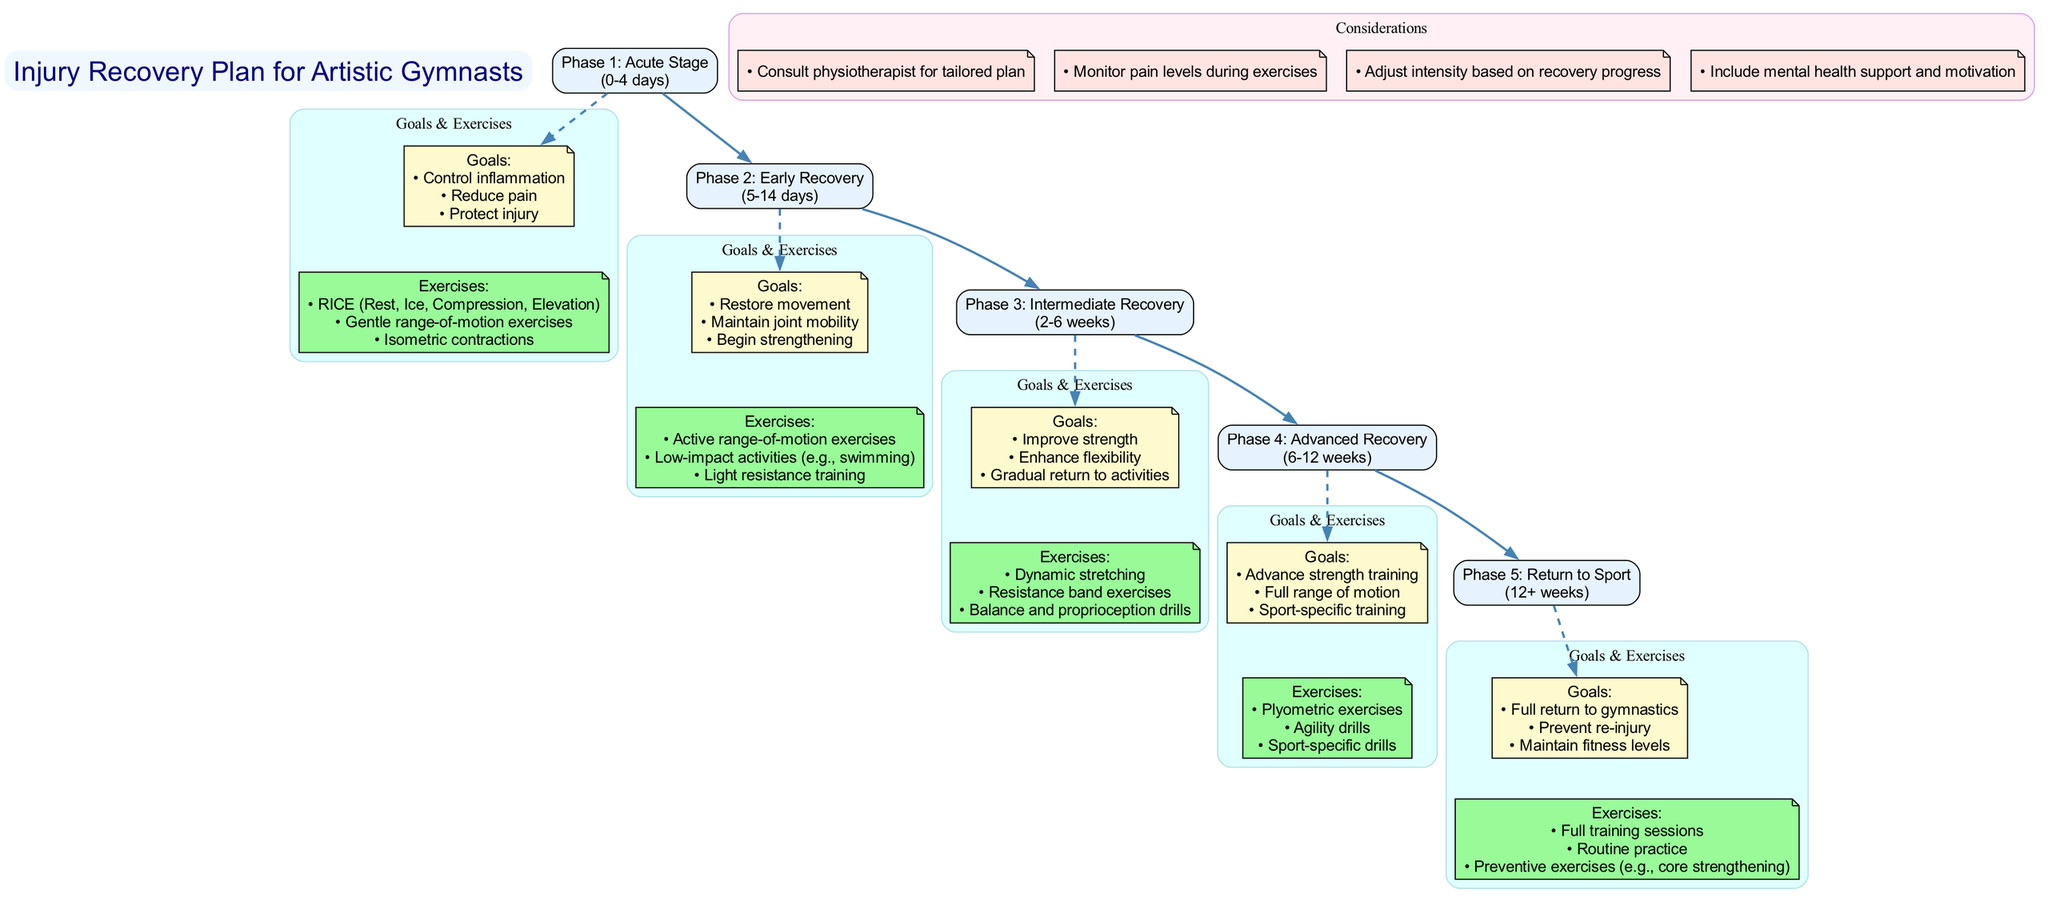What is the duration of Phase 1? The duration of Phase 1, indicated in the diagram, is presented within the parentheses of the phase label. It states "0-4 days" next to "Phase 1: Acute Stage."
Answer: 0-4 days How many goals are listed in Phase 2? To find the number of goals in Phase 2, we look at the contents of the "Goals" node in that phase. There are three goals listed: "Restore movement," "Maintain joint mobility," and "Begin strengthening."
Answer: 3 What type of exercises are included in the Advanced Recovery phase? By examining the "Exercises" node under Phase 4, we see the exercises listed include "Plyometric exercises," "Agility drills," and "Sport-specific drills."
Answer: Plyometric exercises, Agility drills, Sport-specific drills What connects Phase 3 and Phase 4? The connection between Phase 3 and Phase 4 is represented by a direct edge or flow in the diagram. This edge signifies the transition from the Intermediate Recovery phase to the Advanced Recovery phase.
Answer: An edge What is the main goal of Phase 5? The main goal of Phase 5, as seen in the diagram, is stated clearly within the goals listed for that phase. It states, "Full return to gymnastics."
Answer: Full return to gymnastics What are the considerations mentioned in the diagram? The considerations can be found in a separate cluster labeled "Considerations." The diagram lists four considerations that guide the recovery process, such as "Consult physiotherapist for tailored plan."
Answer: Consult physiotherapist for tailored plan, Monitor pain levels during exercises, Adjust intensity based on recovery progress, Include mental health support and motivation How does the duration of Phase 4 compare to that of Phase 2? To compare the durations, we note that Phase 4 lasts "6-12 weeks" while Phase 2 lasts "5-14 days," which indicates that Phase 4 has a longer duration spanning several weeks as opposed to the days of Phase 2.
Answer: Phase 4 is longer What is the total number of phases represented in the diagram? By counting each phase listed in the diagram, we find that there are five distinct phases outlined, each with its respective goals and exercises.
Answer: 5 